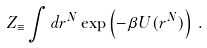Convert formula to latex. <formula><loc_0><loc_0><loc_500><loc_500>Z _ { \equiv } \int d { r } ^ { N } \exp \left ( - \beta U ( { r } ^ { N } ) \right ) \, .</formula> 